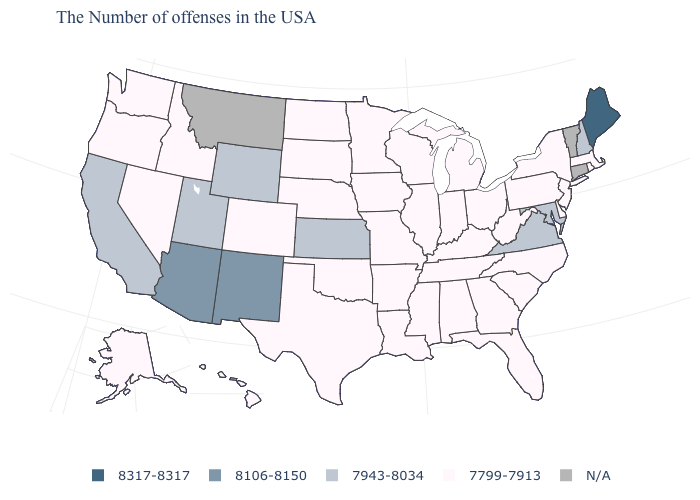What is the value of North Carolina?
Short answer required. 7799-7913. What is the value of Nevada?
Answer briefly. 7799-7913. What is the value of Kansas?
Keep it brief. 7943-8034. Is the legend a continuous bar?
Be succinct. No. Which states hav the highest value in the West?
Give a very brief answer. New Mexico, Arizona. Does the map have missing data?
Write a very short answer. Yes. Does Minnesota have the highest value in the USA?
Quick response, please. No. What is the value of Illinois?
Be succinct. 7799-7913. Name the states that have a value in the range 8317-8317?
Answer briefly. Maine. What is the value of Texas?
Short answer required. 7799-7913. Among the states that border Connecticut , which have the highest value?
Be succinct. Massachusetts, Rhode Island, New York. Which states hav the highest value in the MidWest?
Short answer required. Kansas. Does the first symbol in the legend represent the smallest category?
Be succinct. No. What is the value of Wyoming?
Be succinct. 7943-8034. Which states have the lowest value in the USA?
Give a very brief answer. Massachusetts, Rhode Island, New York, New Jersey, Delaware, Pennsylvania, North Carolina, South Carolina, West Virginia, Ohio, Florida, Georgia, Michigan, Kentucky, Indiana, Alabama, Tennessee, Wisconsin, Illinois, Mississippi, Louisiana, Missouri, Arkansas, Minnesota, Iowa, Nebraska, Oklahoma, Texas, South Dakota, North Dakota, Colorado, Idaho, Nevada, Washington, Oregon, Alaska, Hawaii. 